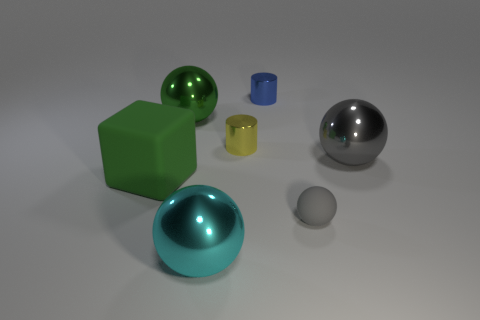Add 2 cyan metal balls. How many objects exist? 9 Subtract all spheres. How many objects are left? 3 Subtract all large blue metal cubes. Subtract all large cyan metal spheres. How many objects are left? 6 Add 2 shiny cylinders. How many shiny cylinders are left? 4 Add 4 tiny gray rubber spheres. How many tiny gray rubber spheres exist? 5 Subtract 1 green spheres. How many objects are left? 6 